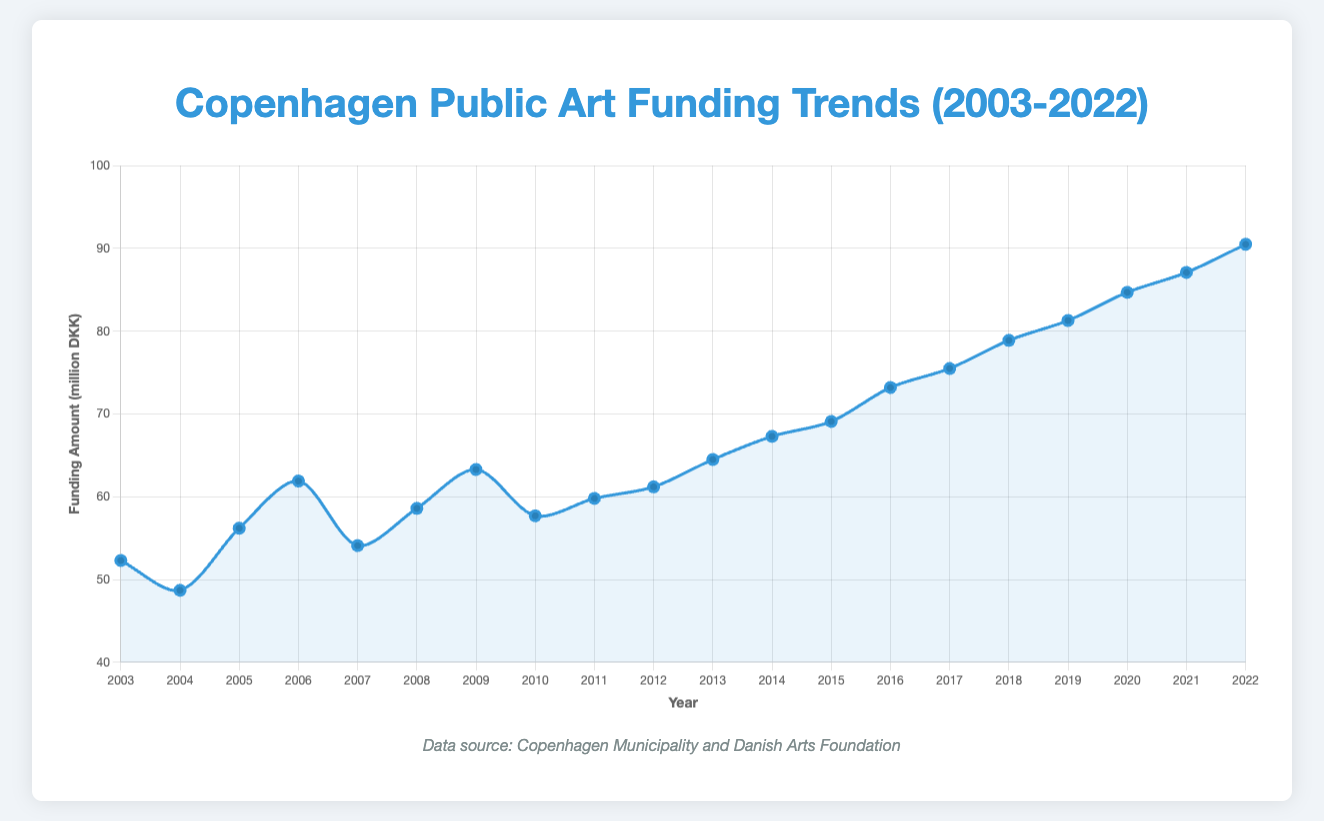Which year saw the highest public art funding? Identify the point with the highest Funding Amount on the y-axis. In this case, 90.5 million DKK in 2022.
Answer: 2022 What is the difference in funding between 2003 and 2022? Subtract the funding amount of 2003 from 2022: 90.5 million DKK - 52.3 million DKK = 38.2 million DKK.
Answer: 38.2 million DKK How many times did funding decrease compared to the previous year? Count the instances where the funding amount for a year is less than the preceding year: namely 2004, 2007, and 2010.
Answer: 3 times What is the average funding amount from 2015 to 2020? Add up the funding amounts from 2015 to 2020 and divide by the number of years: (69.1 + 73.2 + 75.5 + 78.9 + 81.3 + 84.7) / 6 ≈ 77.12 million DKK.
Answer: 77.12 million DKK Which year experienced the largest single-year funding increase? Determine the differences between consecutive years' funding amounts and identify the largest increase: From 2019 (81.3) to 2020 (84.7), a difference of 3.4 million DKK.
Answer: 2020 Is the funding amount in 2009 higher or lower than in 2011? Compare the funding amounts for 2009 (63.3 million DKK) and 2011 (59.8 million DKK).
Answer: Higher By what percentage did the funding increase from 2005 to 2006? Calculate the percentage increase: ((61.9 - 56.2) / 56.2) * 100 ≈ 10.14%.
Answer: 10.14% What is the median funding amount between 2003 and 2022? Sort the data and find the middle value(s). For 20 years, it's the average of the 10th and 11th values: (61.2 + 64.5) / 2 = 62.85 million DKK.
Answer: 62.85 million DKK 